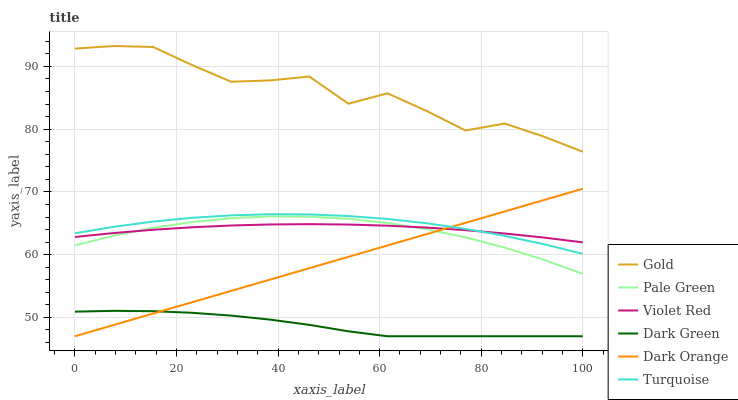Does Violet Red have the minimum area under the curve?
Answer yes or no. No. Does Violet Red have the maximum area under the curve?
Answer yes or no. No. Is Violet Red the smoothest?
Answer yes or no. No. Is Violet Red the roughest?
Answer yes or no. No. Does Violet Red have the lowest value?
Answer yes or no. No. Does Violet Red have the highest value?
Answer yes or no. No. Is Pale Green less than Turquoise?
Answer yes or no. Yes. Is Turquoise greater than Pale Green?
Answer yes or no. Yes. Does Pale Green intersect Turquoise?
Answer yes or no. No. 